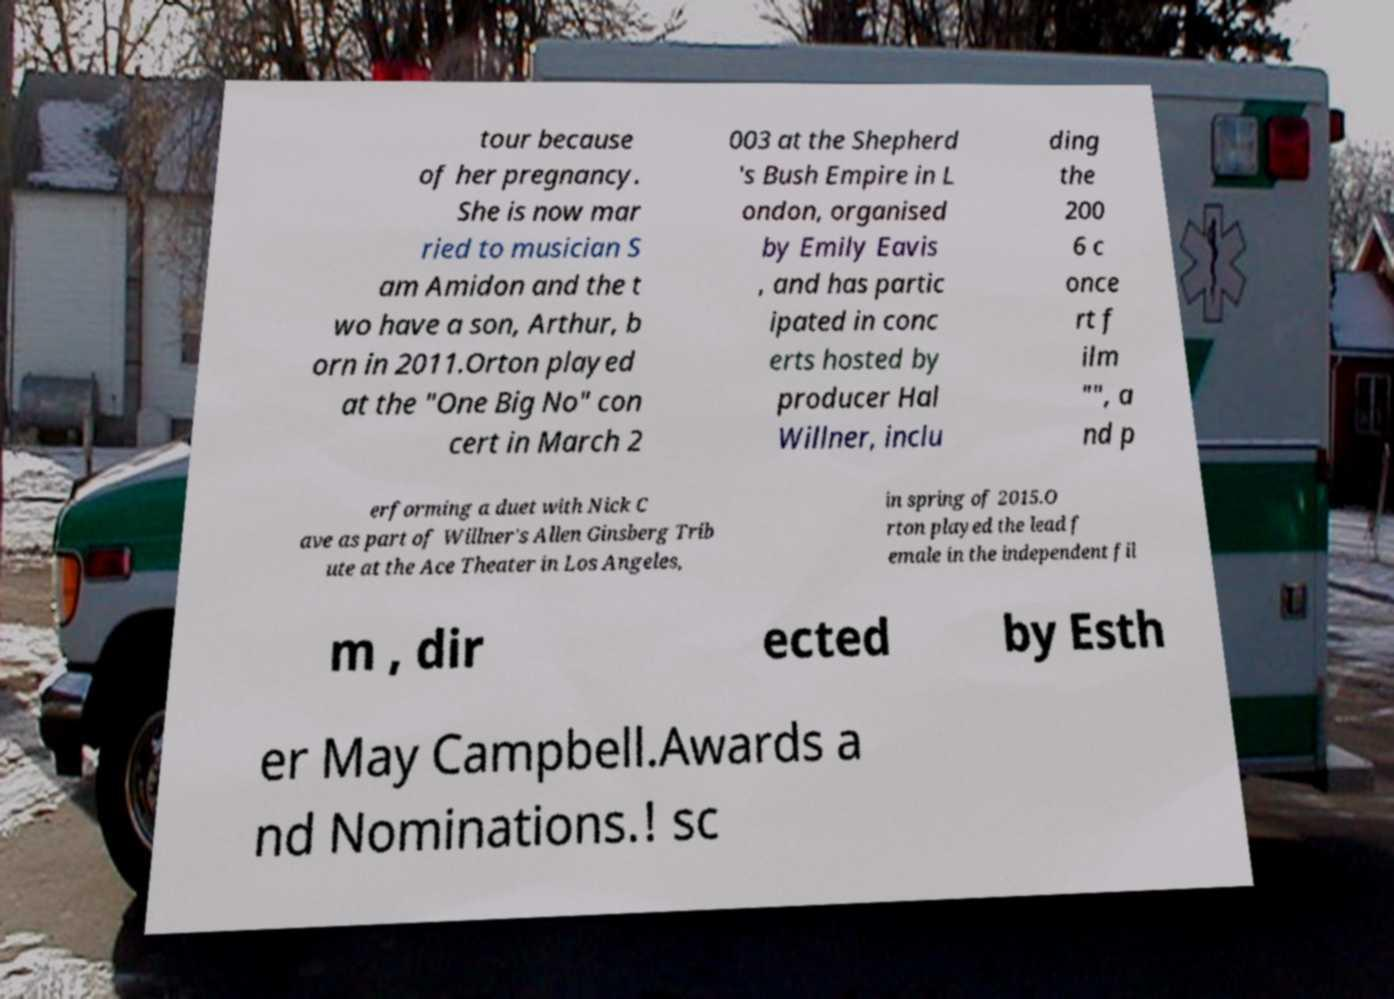What messages or text are displayed in this image? I need them in a readable, typed format. tour because of her pregnancy. She is now mar ried to musician S am Amidon and the t wo have a son, Arthur, b orn in 2011.Orton played at the "One Big No" con cert in March 2 003 at the Shepherd 's Bush Empire in L ondon, organised by Emily Eavis , and has partic ipated in conc erts hosted by producer Hal Willner, inclu ding the 200 6 c once rt f ilm "", a nd p erforming a duet with Nick C ave as part of Willner's Allen Ginsberg Trib ute at the Ace Theater in Los Angeles, in spring of 2015.O rton played the lead f emale in the independent fil m , dir ected by Esth er May Campbell.Awards a nd Nominations.! sc 